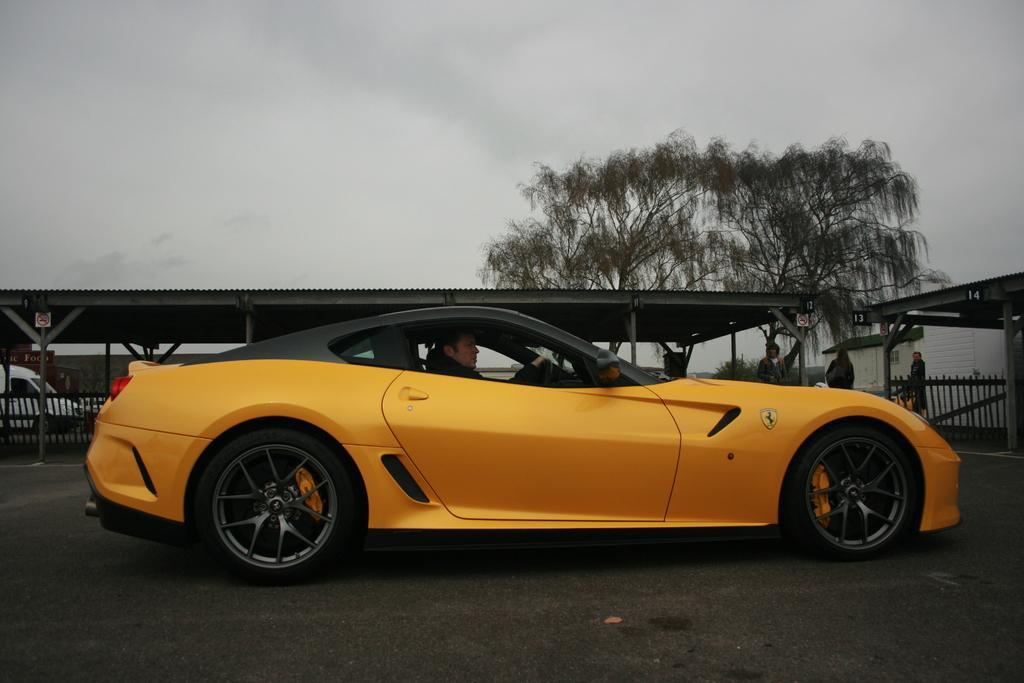In one or two sentences, can you explain what this image depicts? In the center of the image there is a car on the road and there is a man sitting in the car. In the background there are sheds and we can see people. There is a tree. At the top there is sky. 